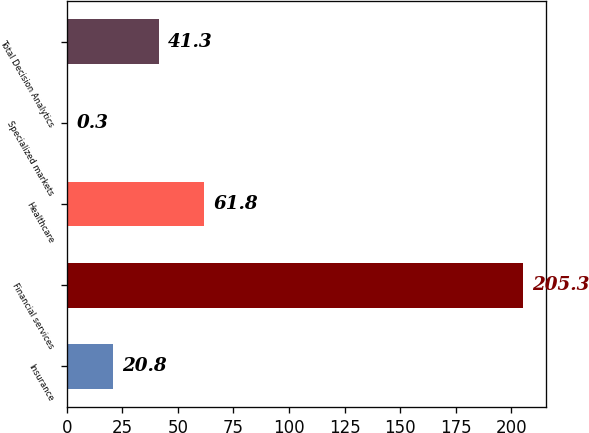Convert chart to OTSL. <chart><loc_0><loc_0><loc_500><loc_500><bar_chart><fcel>Insurance<fcel>Financial services<fcel>Healthcare<fcel>Specialized markets<fcel>Total Decision Analytics<nl><fcel>20.8<fcel>205.3<fcel>61.8<fcel>0.3<fcel>41.3<nl></chart> 